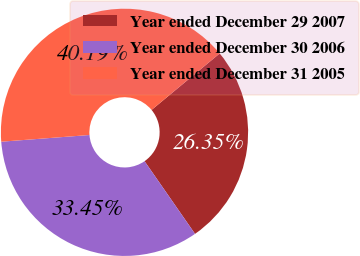Convert chart. <chart><loc_0><loc_0><loc_500><loc_500><pie_chart><fcel>Year ended December 29 2007<fcel>Year ended December 30 2006<fcel>Year ended December 31 2005<nl><fcel>26.35%<fcel>33.45%<fcel>40.19%<nl></chart> 